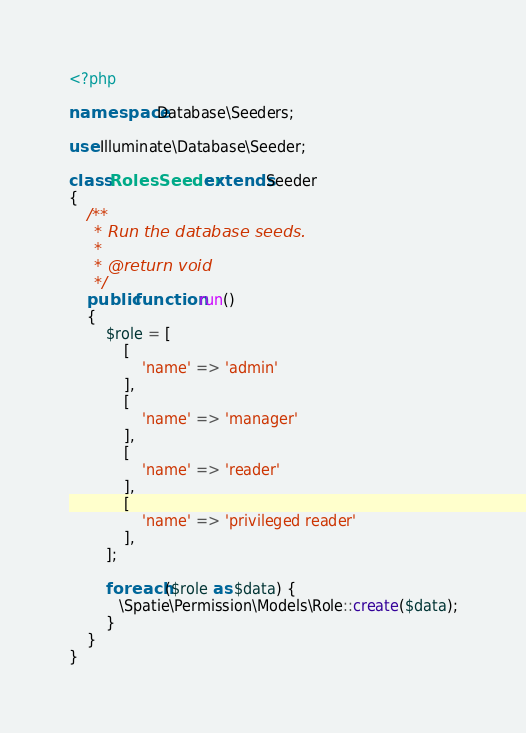Convert code to text. <code><loc_0><loc_0><loc_500><loc_500><_PHP_><?php

namespace Database\Seeders;

use Illuminate\Database\Seeder;

class RolesSeeder extends Seeder
{
    /**
     * Run the database seeds.
     *
     * @return void
     */
    public function run()
    {
        $role = [
            [
                'name' => 'admin'
            ],
            [
                'name' => 'manager'
            ],
            [
                'name' => 'reader'
            ],
            [
                'name' => 'privileged reader'
            ],
        ];

        foreach ($role as $data) {
           \Spatie\Permission\Models\Role::create($data);
        }
    }
}
</code> 